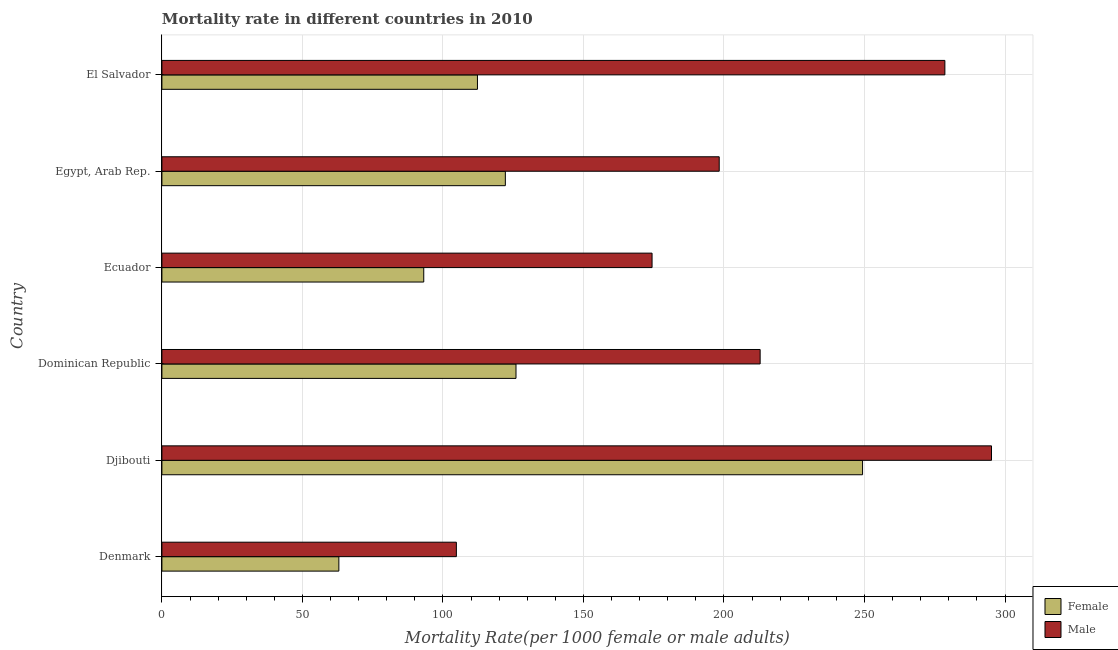Are the number of bars per tick equal to the number of legend labels?
Your answer should be very brief. Yes. Are the number of bars on each tick of the Y-axis equal?
Your response must be concise. Yes. How many bars are there on the 4th tick from the top?
Offer a very short reply. 2. How many bars are there on the 2nd tick from the bottom?
Keep it short and to the point. 2. In how many cases, is the number of bars for a given country not equal to the number of legend labels?
Offer a terse response. 0. What is the male mortality rate in El Salvador?
Your response must be concise. 278.6. Across all countries, what is the maximum male mortality rate?
Keep it short and to the point. 295.18. Across all countries, what is the minimum male mortality rate?
Make the answer very short. 104.78. In which country was the male mortality rate maximum?
Your answer should be very brief. Djibouti. In which country was the female mortality rate minimum?
Offer a very short reply. Denmark. What is the total male mortality rate in the graph?
Your answer should be very brief. 1264.13. What is the difference between the female mortality rate in Denmark and that in Ecuador?
Ensure brevity in your answer.  -30.21. What is the difference between the male mortality rate in Dominican Republic and the female mortality rate in Egypt, Arab Rep.?
Provide a short and direct response. 90.66. What is the average female mortality rate per country?
Offer a terse response. 127.65. What is the difference between the male mortality rate and female mortality rate in Egypt, Arab Rep.?
Offer a very short reply. 76.1. What is the ratio of the female mortality rate in Ecuador to that in El Salvador?
Provide a succinct answer. 0.83. Is the male mortality rate in Dominican Republic less than that in Egypt, Arab Rep.?
Your answer should be compact. No. What is the difference between the highest and the second highest female mortality rate?
Give a very brief answer. 123.31. What is the difference between the highest and the lowest male mortality rate?
Your answer should be compact. 190.4. In how many countries, is the male mortality rate greater than the average male mortality rate taken over all countries?
Provide a short and direct response. 3. What does the 2nd bar from the bottom in Ecuador represents?
Your answer should be compact. Male. How many bars are there?
Keep it short and to the point. 12. How many countries are there in the graph?
Your answer should be very brief. 6. Are the values on the major ticks of X-axis written in scientific E-notation?
Give a very brief answer. No. How are the legend labels stacked?
Your answer should be very brief. Vertical. What is the title of the graph?
Offer a very short reply. Mortality rate in different countries in 2010. What is the label or title of the X-axis?
Provide a succinct answer. Mortality Rate(per 1000 female or male adults). What is the label or title of the Y-axis?
Offer a terse response. Country. What is the Mortality Rate(per 1000 female or male adults) of Female in Denmark?
Your answer should be very brief. 62.96. What is the Mortality Rate(per 1000 female or male adults) in Male in Denmark?
Your response must be concise. 104.78. What is the Mortality Rate(per 1000 female or male adults) in Female in Djibouti?
Give a very brief answer. 249.31. What is the Mortality Rate(per 1000 female or male adults) in Male in Djibouti?
Give a very brief answer. 295.18. What is the Mortality Rate(per 1000 female or male adults) in Female in Dominican Republic?
Ensure brevity in your answer.  125.99. What is the Mortality Rate(per 1000 female or male adults) in Male in Dominican Republic?
Provide a succinct answer. 212.87. What is the Mortality Rate(per 1000 female or male adults) in Female in Ecuador?
Your response must be concise. 93.17. What is the Mortality Rate(per 1000 female or male adults) of Male in Ecuador?
Offer a terse response. 174.41. What is the Mortality Rate(per 1000 female or male adults) of Female in Egypt, Arab Rep.?
Offer a terse response. 122.2. What is the Mortality Rate(per 1000 female or male adults) in Male in Egypt, Arab Rep.?
Offer a terse response. 198.3. What is the Mortality Rate(per 1000 female or male adults) in Female in El Salvador?
Ensure brevity in your answer.  112.28. What is the Mortality Rate(per 1000 female or male adults) in Male in El Salvador?
Your answer should be compact. 278.6. Across all countries, what is the maximum Mortality Rate(per 1000 female or male adults) of Female?
Give a very brief answer. 249.31. Across all countries, what is the maximum Mortality Rate(per 1000 female or male adults) of Male?
Your answer should be very brief. 295.18. Across all countries, what is the minimum Mortality Rate(per 1000 female or male adults) of Female?
Provide a short and direct response. 62.96. Across all countries, what is the minimum Mortality Rate(per 1000 female or male adults) in Male?
Provide a short and direct response. 104.78. What is the total Mortality Rate(per 1000 female or male adults) of Female in the graph?
Make the answer very short. 765.92. What is the total Mortality Rate(per 1000 female or male adults) in Male in the graph?
Your answer should be very brief. 1264.13. What is the difference between the Mortality Rate(per 1000 female or male adults) of Female in Denmark and that in Djibouti?
Your answer should be compact. -186.34. What is the difference between the Mortality Rate(per 1000 female or male adults) in Male in Denmark and that in Djibouti?
Keep it short and to the point. -190.4. What is the difference between the Mortality Rate(per 1000 female or male adults) of Female in Denmark and that in Dominican Republic?
Give a very brief answer. -63.03. What is the difference between the Mortality Rate(per 1000 female or male adults) of Male in Denmark and that in Dominican Republic?
Your response must be concise. -108.09. What is the difference between the Mortality Rate(per 1000 female or male adults) in Female in Denmark and that in Ecuador?
Ensure brevity in your answer.  -30.21. What is the difference between the Mortality Rate(per 1000 female or male adults) in Male in Denmark and that in Ecuador?
Make the answer very short. -69.63. What is the difference between the Mortality Rate(per 1000 female or male adults) in Female in Denmark and that in Egypt, Arab Rep.?
Your answer should be very brief. -59.24. What is the difference between the Mortality Rate(per 1000 female or male adults) of Male in Denmark and that in Egypt, Arab Rep.?
Offer a terse response. -93.52. What is the difference between the Mortality Rate(per 1000 female or male adults) in Female in Denmark and that in El Salvador?
Make the answer very short. -49.32. What is the difference between the Mortality Rate(per 1000 female or male adults) of Male in Denmark and that in El Salvador?
Your answer should be compact. -173.82. What is the difference between the Mortality Rate(per 1000 female or male adults) of Female in Djibouti and that in Dominican Republic?
Keep it short and to the point. 123.31. What is the difference between the Mortality Rate(per 1000 female or male adults) of Male in Djibouti and that in Dominican Republic?
Your response must be concise. 82.32. What is the difference between the Mortality Rate(per 1000 female or male adults) of Female in Djibouti and that in Ecuador?
Provide a short and direct response. 156.14. What is the difference between the Mortality Rate(per 1000 female or male adults) in Male in Djibouti and that in Ecuador?
Your answer should be compact. 120.78. What is the difference between the Mortality Rate(per 1000 female or male adults) of Female in Djibouti and that in Egypt, Arab Rep.?
Offer a terse response. 127.1. What is the difference between the Mortality Rate(per 1000 female or male adults) in Male in Djibouti and that in Egypt, Arab Rep.?
Offer a very short reply. 96.88. What is the difference between the Mortality Rate(per 1000 female or male adults) of Female in Djibouti and that in El Salvador?
Offer a terse response. 137.03. What is the difference between the Mortality Rate(per 1000 female or male adults) in Male in Djibouti and that in El Salvador?
Your response must be concise. 16.59. What is the difference between the Mortality Rate(per 1000 female or male adults) in Female in Dominican Republic and that in Ecuador?
Give a very brief answer. 32.82. What is the difference between the Mortality Rate(per 1000 female or male adults) of Male in Dominican Republic and that in Ecuador?
Offer a terse response. 38.46. What is the difference between the Mortality Rate(per 1000 female or male adults) of Female in Dominican Republic and that in Egypt, Arab Rep.?
Provide a short and direct response. 3.79. What is the difference between the Mortality Rate(per 1000 female or male adults) in Male in Dominican Republic and that in Egypt, Arab Rep.?
Ensure brevity in your answer.  14.56. What is the difference between the Mortality Rate(per 1000 female or male adults) of Female in Dominican Republic and that in El Salvador?
Your answer should be compact. 13.71. What is the difference between the Mortality Rate(per 1000 female or male adults) in Male in Dominican Republic and that in El Salvador?
Make the answer very short. -65.73. What is the difference between the Mortality Rate(per 1000 female or male adults) of Female in Ecuador and that in Egypt, Arab Rep.?
Offer a terse response. -29.03. What is the difference between the Mortality Rate(per 1000 female or male adults) of Male in Ecuador and that in Egypt, Arab Rep.?
Provide a short and direct response. -23.9. What is the difference between the Mortality Rate(per 1000 female or male adults) in Female in Ecuador and that in El Salvador?
Give a very brief answer. -19.11. What is the difference between the Mortality Rate(per 1000 female or male adults) of Male in Ecuador and that in El Salvador?
Make the answer very short. -104.19. What is the difference between the Mortality Rate(per 1000 female or male adults) of Female in Egypt, Arab Rep. and that in El Salvador?
Keep it short and to the point. 9.92. What is the difference between the Mortality Rate(per 1000 female or male adults) of Male in Egypt, Arab Rep. and that in El Salvador?
Offer a very short reply. -80.29. What is the difference between the Mortality Rate(per 1000 female or male adults) of Female in Denmark and the Mortality Rate(per 1000 female or male adults) of Male in Djibouti?
Provide a succinct answer. -232.22. What is the difference between the Mortality Rate(per 1000 female or male adults) in Female in Denmark and the Mortality Rate(per 1000 female or male adults) in Male in Dominican Republic?
Your response must be concise. -149.9. What is the difference between the Mortality Rate(per 1000 female or male adults) in Female in Denmark and the Mortality Rate(per 1000 female or male adults) in Male in Ecuador?
Offer a very short reply. -111.44. What is the difference between the Mortality Rate(per 1000 female or male adults) of Female in Denmark and the Mortality Rate(per 1000 female or male adults) of Male in Egypt, Arab Rep.?
Provide a succinct answer. -135.34. What is the difference between the Mortality Rate(per 1000 female or male adults) of Female in Denmark and the Mortality Rate(per 1000 female or male adults) of Male in El Salvador?
Your answer should be very brief. -215.63. What is the difference between the Mortality Rate(per 1000 female or male adults) of Female in Djibouti and the Mortality Rate(per 1000 female or male adults) of Male in Dominican Republic?
Provide a succinct answer. 36.44. What is the difference between the Mortality Rate(per 1000 female or male adults) in Female in Djibouti and the Mortality Rate(per 1000 female or male adults) in Male in Ecuador?
Your response must be concise. 74.9. What is the difference between the Mortality Rate(per 1000 female or male adults) of Female in Djibouti and the Mortality Rate(per 1000 female or male adults) of Male in Egypt, Arab Rep.?
Make the answer very short. 51. What is the difference between the Mortality Rate(per 1000 female or male adults) in Female in Djibouti and the Mortality Rate(per 1000 female or male adults) in Male in El Salvador?
Provide a succinct answer. -29.29. What is the difference between the Mortality Rate(per 1000 female or male adults) in Female in Dominican Republic and the Mortality Rate(per 1000 female or male adults) in Male in Ecuador?
Make the answer very short. -48.41. What is the difference between the Mortality Rate(per 1000 female or male adults) of Female in Dominican Republic and the Mortality Rate(per 1000 female or male adults) of Male in Egypt, Arab Rep.?
Your answer should be very brief. -72.31. What is the difference between the Mortality Rate(per 1000 female or male adults) in Female in Dominican Republic and the Mortality Rate(per 1000 female or male adults) in Male in El Salvador?
Offer a very short reply. -152.6. What is the difference between the Mortality Rate(per 1000 female or male adults) in Female in Ecuador and the Mortality Rate(per 1000 female or male adults) in Male in Egypt, Arab Rep.?
Keep it short and to the point. -105.13. What is the difference between the Mortality Rate(per 1000 female or male adults) in Female in Ecuador and the Mortality Rate(per 1000 female or male adults) in Male in El Salvador?
Give a very brief answer. -185.43. What is the difference between the Mortality Rate(per 1000 female or male adults) of Female in Egypt, Arab Rep. and the Mortality Rate(per 1000 female or male adults) of Male in El Salvador?
Offer a terse response. -156.39. What is the average Mortality Rate(per 1000 female or male adults) in Female per country?
Give a very brief answer. 127.65. What is the average Mortality Rate(per 1000 female or male adults) in Male per country?
Your answer should be compact. 210.69. What is the difference between the Mortality Rate(per 1000 female or male adults) in Female and Mortality Rate(per 1000 female or male adults) in Male in Denmark?
Keep it short and to the point. -41.81. What is the difference between the Mortality Rate(per 1000 female or male adults) in Female and Mortality Rate(per 1000 female or male adults) in Male in Djibouti?
Offer a terse response. -45.88. What is the difference between the Mortality Rate(per 1000 female or male adults) of Female and Mortality Rate(per 1000 female or male adults) of Male in Dominican Republic?
Give a very brief answer. -86.87. What is the difference between the Mortality Rate(per 1000 female or male adults) in Female and Mortality Rate(per 1000 female or male adults) in Male in Ecuador?
Provide a succinct answer. -81.24. What is the difference between the Mortality Rate(per 1000 female or male adults) in Female and Mortality Rate(per 1000 female or male adults) in Male in Egypt, Arab Rep.?
Provide a short and direct response. -76.1. What is the difference between the Mortality Rate(per 1000 female or male adults) of Female and Mortality Rate(per 1000 female or male adults) of Male in El Salvador?
Offer a terse response. -166.32. What is the ratio of the Mortality Rate(per 1000 female or male adults) in Female in Denmark to that in Djibouti?
Ensure brevity in your answer.  0.25. What is the ratio of the Mortality Rate(per 1000 female or male adults) in Male in Denmark to that in Djibouti?
Your response must be concise. 0.35. What is the ratio of the Mortality Rate(per 1000 female or male adults) of Female in Denmark to that in Dominican Republic?
Make the answer very short. 0.5. What is the ratio of the Mortality Rate(per 1000 female or male adults) of Male in Denmark to that in Dominican Republic?
Offer a terse response. 0.49. What is the ratio of the Mortality Rate(per 1000 female or male adults) in Female in Denmark to that in Ecuador?
Provide a short and direct response. 0.68. What is the ratio of the Mortality Rate(per 1000 female or male adults) in Male in Denmark to that in Ecuador?
Your answer should be compact. 0.6. What is the ratio of the Mortality Rate(per 1000 female or male adults) of Female in Denmark to that in Egypt, Arab Rep.?
Your response must be concise. 0.52. What is the ratio of the Mortality Rate(per 1000 female or male adults) in Male in Denmark to that in Egypt, Arab Rep.?
Your answer should be very brief. 0.53. What is the ratio of the Mortality Rate(per 1000 female or male adults) in Female in Denmark to that in El Salvador?
Give a very brief answer. 0.56. What is the ratio of the Mortality Rate(per 1000 female or male adults) in Male in Denmark to that in El Salvador?
Ensure brevity in your answer.  0.38. What is the ratio of the Mortality Rate(per 1000 female or male adults) of Female in Djibouti to that in Dominican Republic?
Provide a short and direct response. 1.98. What is the ratio of the Mortality Rate(per 1000 female or male adults) in Male in Djibouti to that in Dominican Republic?
Offer a very short reply. 1.39. What is the ratio of the Mortality Rate(per 1000 female or male adults) of Female in Djibouti to that in Ecuador?
Provide a succinct answer. 2.68. What is the ratio of the Mortality Rate(per 1000 female or male adults) in Male in Djibouti to that in Ecuador?
Your answer should be very brief. 1.69. What is the ratio of the Mortality Rate(per 1000 female or male adults) of Female in Djibouti to that in Egypt, Arab Rep.?
Provide a succinct answer. 2.04. What is the ratio of the Mortality Rate(per 1000 female or male adults) in Male in Djibouti to that in Egypt, Arab Rep.?
Provide a short and direct response. 1.49. What is the ratio of the Mortality Rate(per 1000 female or male adults) of Female in Djibouti to that in El Salvador?
Ensure brevity in your answer.  2.22. What is the ratio of the Mortality Rate(per 1000 female or male adults) in Male in Djibouti to that in El Salvador?
Ensure brevity in your answer.  1.06. What is the ratio of the Mortality Rate(per 1000 female or male adults) in Female in Dominican Republic to that in Ecuador?
Make the answer very short. 1.35. What is the ratio of the Mortality Rate(per 1000 female or male adults) of Male in Dominican Republic to that in Ecuador?
Give a very brief answer. 1.22. What is the ratio of the Mortality Rate(per 1000 female or male adults) in Female in Dominican Republic to that in Egypt, Arab Rep.?
Keep it short and to the point. 1.03. What is the ratio of the Mortality Rate(per 1000 female or male adults) in Male in Dominican Republic to that in Egypt, Arab Rep.?
Offer a very short reply. 1.07. What is the ratio of the Mortality Rate(per 1000 female or male adults) of Female in Dominican Republic to that in El Salvador?
Provide a succinct answer. 1.12. What is the ratio of the Mortality Rate(per 1000 female or male adults) in Male in Dominican Republic to that in El Salvador?
Ensure brevity in your answer.  0.76. What is the ratio of the Mortality Rate(per 1000 female or male adults) of Female in Ecuador to that in Egypt, Arab Rep.?
Provide a succinct answer. 0.76. What is the ratio of the Mortality Rate(per 1000 female or male adults) in Male in Ecuador to that in Egypt, Arab Rep.?
Your response must be concise. 0.88. What is the ratio of the Mortality Rate(per 1000 female or male adults) in Female in Ecuador to that in El Salvador?
Your response must be concise. 0.83. What is the ratio of the Mortality Rate(per 1000 female or male adults) of Male in Ecuador to that in El Salvador?
Provide a short and direct response. 0.63. What is the ratio of the Mortality Rate(per 1000 female or male adults) of Female in Egypt, Arab Rep. to that in El Salvador?
Your response must be concise. 1.09. What is the ratio of the Mortality Rate(per 1000 female or male adults) of Male in Egypt, Arab Rep. to that in El Salvador?
Offer a very short reply. 0.71. What is the difference between the highest and the second highest Mortality Rate(per 1000 female or male adults) of Female?
Ensure brevity in your answer.  123.31. What is the difference between the highest and the second highest Mortality Rate(per 1000 female or male adults) of Male?
Offer a terse response. 16.59. What is the difference between the highest and the lowest Mortality Rate(per 1000 female or male adults) of Female?
Your answer should be compact. 186.34. What is the difference between the highest and the lowest Mortality Rate(per 1000 female or male adults) of Male?
Ensure brevity in your answer.  190.4. 